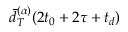<formula> <loc_0><loc_0><loc_500><loc_500>\ B a r { d } _ { T } ^ { ( \alpha ) } ( 2 t _ { 0 } + 2 \tau + t _ { d } )</formula> 